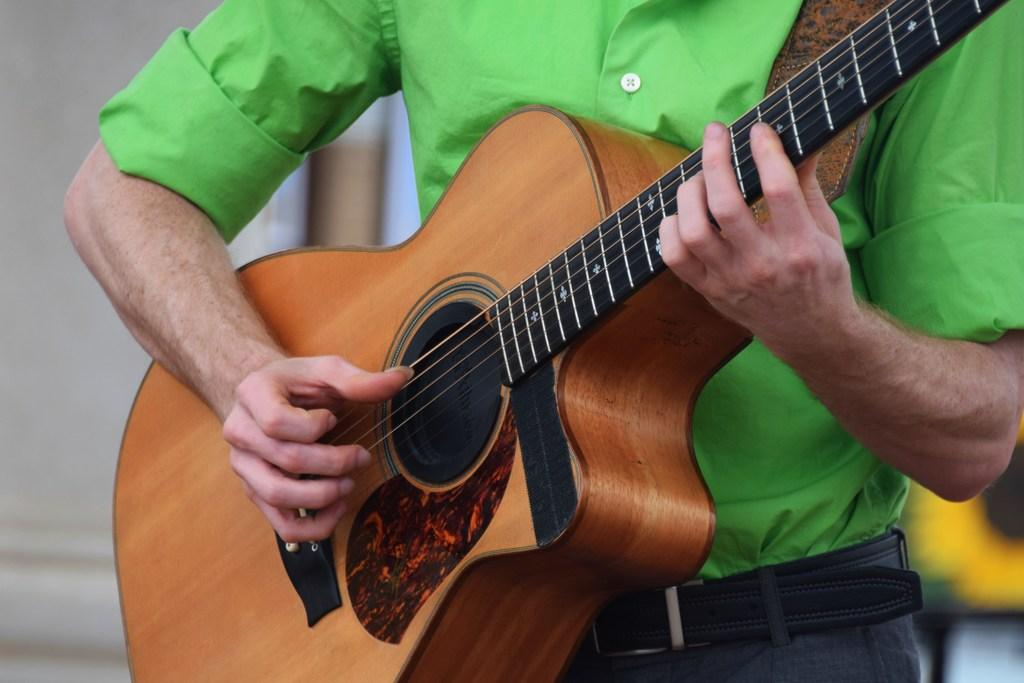Who is present in the image? There is a person in the image. What is the person doing in the image? The person is standing in the image. What object is the person holding in the image? The person is holding a guitar in his hand. How many children are flying in the image? There are no children or flying depicted in the image; it features a person holding a guitar. 